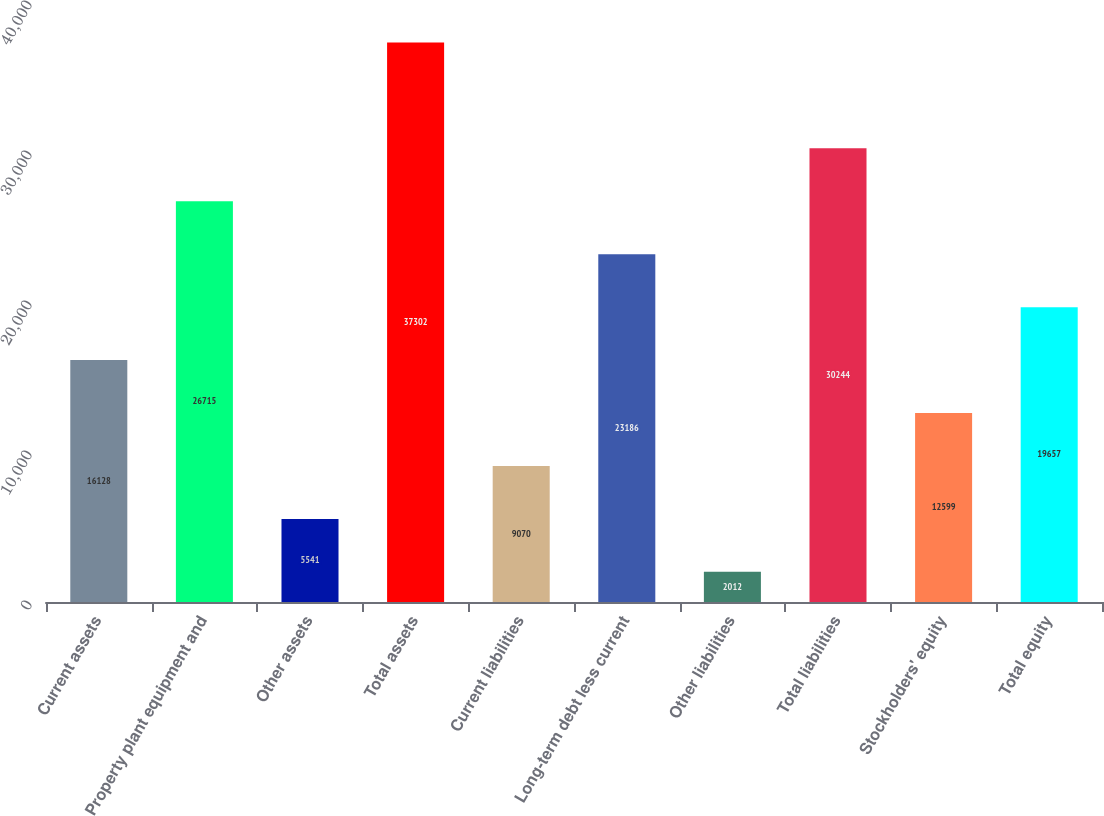<chart> <loc_0><loc_0><loc_500><loc_500><bar_chart><fcel>Current assets<fcel>Property plant equipment and<fcel>Other assets<fcel>Total assets<fcel>Current liabilities<fcel>Long-term debt less current<fcel>Other liabilities<fcel>Total liabilities<fcel>Stockholders' equity<fcel>Total equity<nl><fcel>16128<fcel>26715<fcel>5541<fcel>37302<fcel>9070<fcel>23186<fcel>2012<fcel>30244<fcel>12599<fcel>19657<nl></chart> 